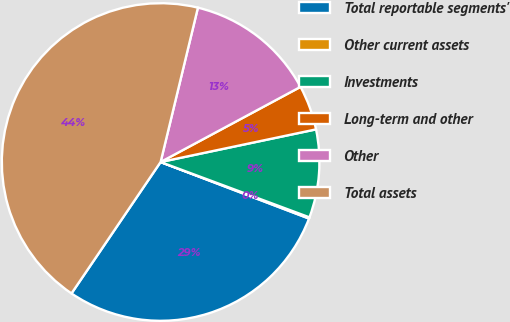Convert chart to OTSL. <chart><loc_0><loc_0><loc_500><loc_500><pie_chart><fcel>Total reportable segments'<fcel>Other current assets<fcel>Investments<fcel>Long-term and other<fcel>Other<fcel>Total assets<nl><fcel>28.69%<fcel>0.13%<fcel>8.96%<fcel>4.55%<fcel>13.38%<fcel>44.29%<nl></chart> 